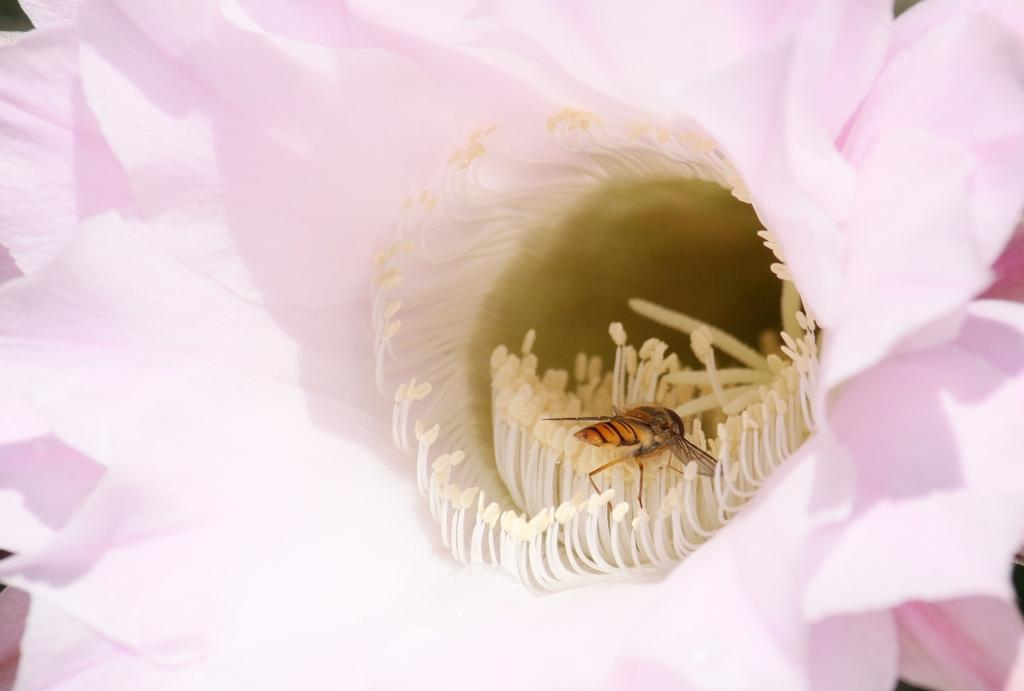What is the main subject of the image? There is a flower in the image. Can you describe the color of the flower? The flower is pink in color. Are there any other objects or creatures present in the image? Yes, there is a fly on the flower. How many beads are present on the flower in the image? There are no beads present on the flower in the image. 